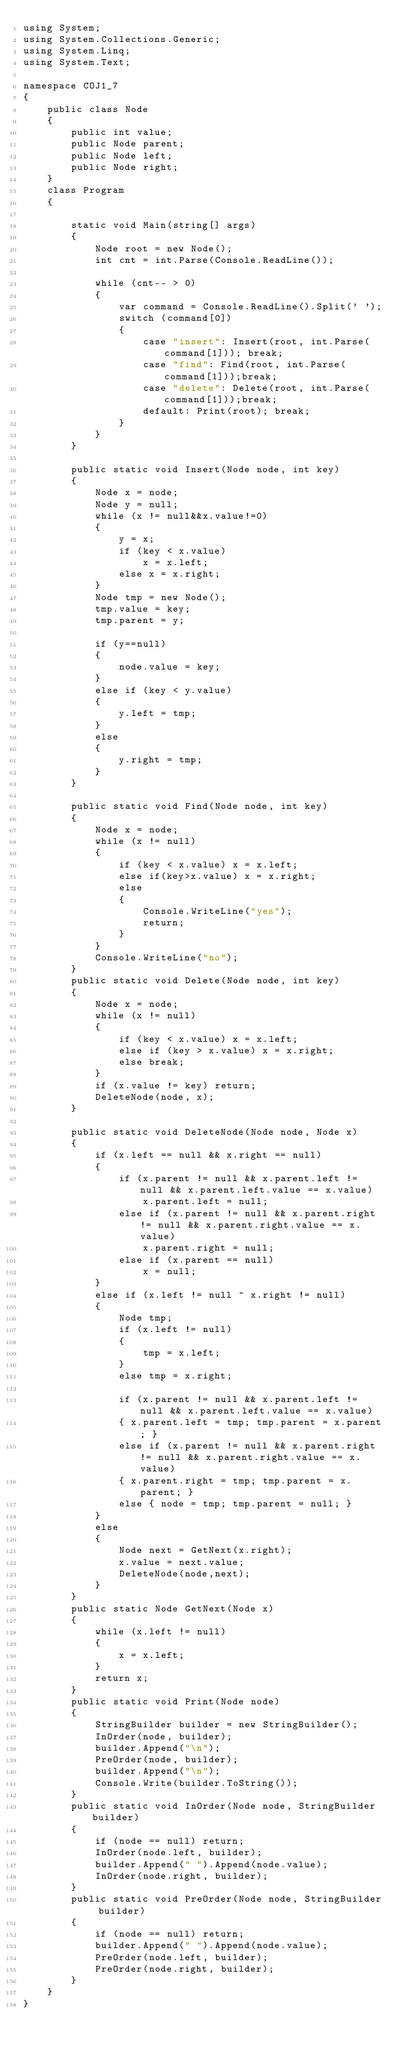Convert code to text. <code><loc_0><loc_0><loc_500><loc_500><_C#_>using System;
using System.Collections.Generic;
using System.Linq;
using System.Text;

namespace COJ1_7
{
    public class Node
    {
        public int value;
        public Node parent;
        public Node left;
        public Node right;
    }
    class Program
    {

        static void Main(string[] args)
        {
            Node root = new Node();
            int cnt = int.Parse(Console.ReadLine());

            while (cnt-- > 0)
            {
                var command = Console.ReadLine().Split(' ');
                switch (command[0])
                {
                    case "insert": Insert(root, int.Parse(command[1])); break;
                    case "find": Find(root, int.Parse(command[1]));break;
                    case "delete": Delete(root, int.Parse(command[1]));break;
                    default: Print(root); break;
                }
            }
        }

        public static void Insert(Node node, int key)
        {
            Node x = node;
            Node y = null;
            while (x != null&&x.value!=0)
            {
                y = x;
                if (key < x.value)
                    x = x.left;
                else x = x.right;
            }
            Node tmp = new Node();
            tmp.value = key;
            tmp.parent = y;

            if (y==null) 
            {
                node.value = key;
            }
            else if (key < y.value)
            {
                y.left = tmp;
            }
            else
            {
                y.right = tmp;
            }
        }

        public static void Find(Node node, int key)
        {
            Node x = node;
            while (x != null)
            {
                if (key < x.value) x = x.left;
                else if(key>x.value) x = x.right;
                else
                {
                    Console.WriteLine("yes");
                    return;
                }
            }
            Console.WriteLine("no");
        }
        public static void Delete(Node node, int key)
        {
            Node x = node;
            while (x != null)
            {
                if (key < x.value) x = x.left;
                else if (key > x.value) x = x.right;
                else break;
            }
            if (x.value != key) return;
            DeleteNode(node, x);            
        }

        public static void DeleteNode(Node node, Node x)
        {
            if (x.left == null && x.right == null)
            {
                if (x.parent != null && x.parent.left != null && x.parent.left.value == x.value)
                    x.parent.left = null;
                else if (x.parent != null && x.parent.right != null && x.parent.right.value == x.value)
                    x.parent.right = null;
                else if (x.parent == null)
                    x = null;
            }
            else if (x.left != null ^ x.right != null)
            {
                Node tmp;
                if (x.left != null)
                {
                    tmp = x.left;
                }
                else tmp = x.right;

                if (x.parent != null && x.parent.left != null && x.parent.left.value == x.value)
                { x.parent.left = tmp; tmp.parent = x.parent; }
                else if (x.parent != null && x.parent.right != null && x.parent.right.value == x.value)
                { x.parent.right = tmp; tmp.parent = x.parent; }
                else { node = tmp; tmp.parent = null; }
            }
            else
            {
                Node next = GetNext(x.right);
                x.value = next.value;
                DeleteNode(node,next);
            }
        }
        public static Node GetNext(Node x)
        {
            while (x.left != null)
            {
                x = x.left;
            }
            return x;
        }
        public static void Print(Node node)
        {
            StringBuilder builder = new StringBuilder();
            InOrder(node, builder);
            builder.Append("\n");
            PreOrder(node, builder);
            builder.Append("\n");
            Console.Write(builder.ToString());
        }
        public static void InOrder(Node node, StringBuilder builder)
        {
            if (node == null) return;
            InOrder(node.left, builder);
            builder.Append(" ").Append(node.value);
            InOrder(node.right, builder);
        }
        public static void PreOrder(Node node, StringBuilder builder)
        {
            if (node == null) return;
            builder.Append(" ").Append(node.value);
            PreOrder(node.left, builder);
            PreOrder(node.right, builder);
        }
    }
}</code> 